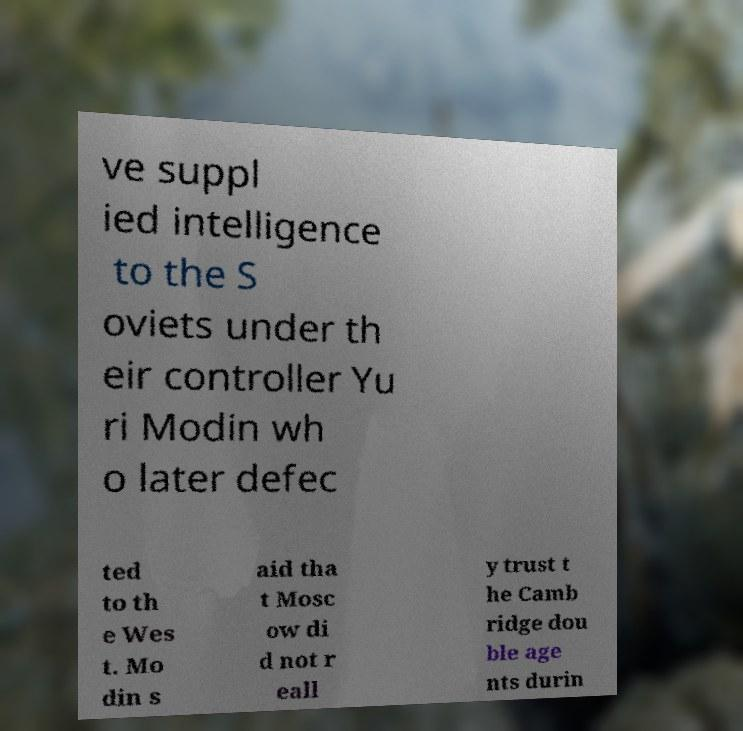Could you assist in decoding the text presented in this image and type it out clearly? ve suppl ied intelligence to the S oviets under th eir controller Yu ri Modin wh o later defec ted to th e Wes t. Mo din s aid tha t Mosc ow di d not r eall y trust t he Camb ridge dou ble age nts durin 